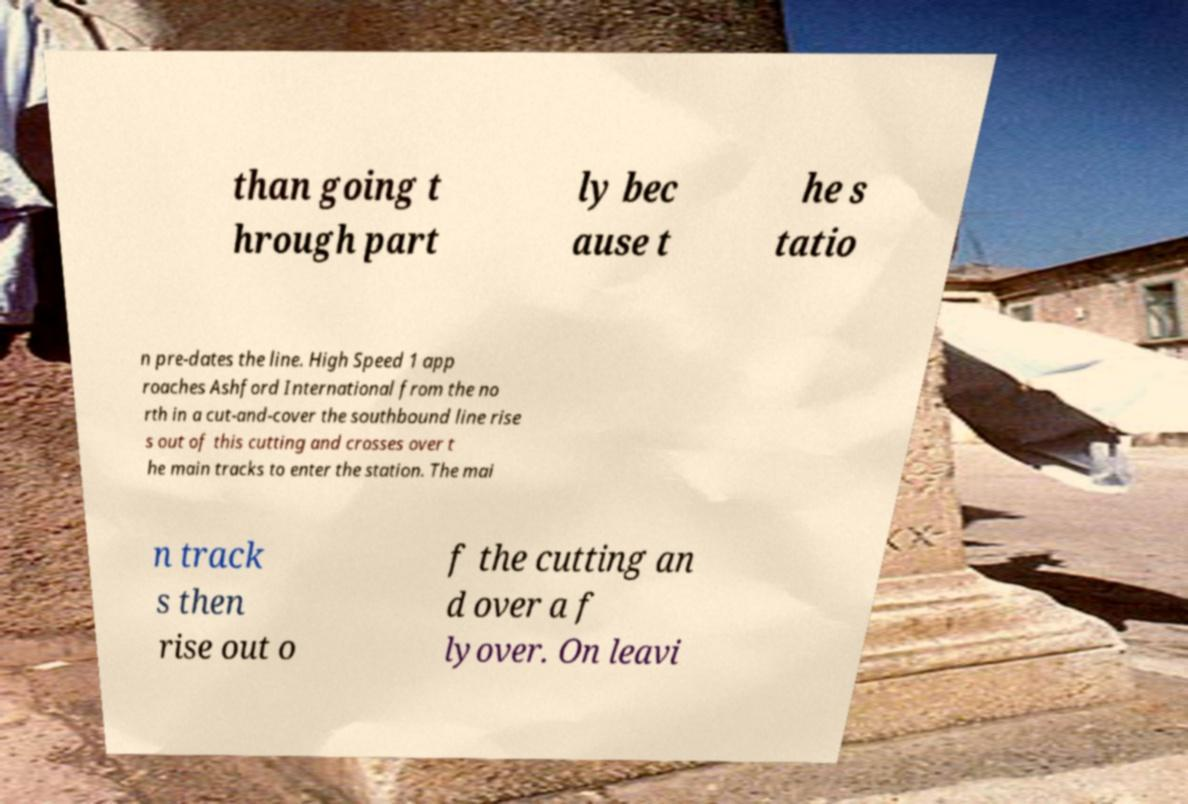Please identify and transcribe the text found in this image. than going t hrough part ly bec ause t he s tatio n pre-dates the line. High Speed 1 app roaches Ashford International from the no rth in a cut-and-cover the southbound line rise s out of this cutting and crosses over t he main tracks to enter the station. The mai n track s then rise out o f the cutting an d over a f lyover. On leavi 